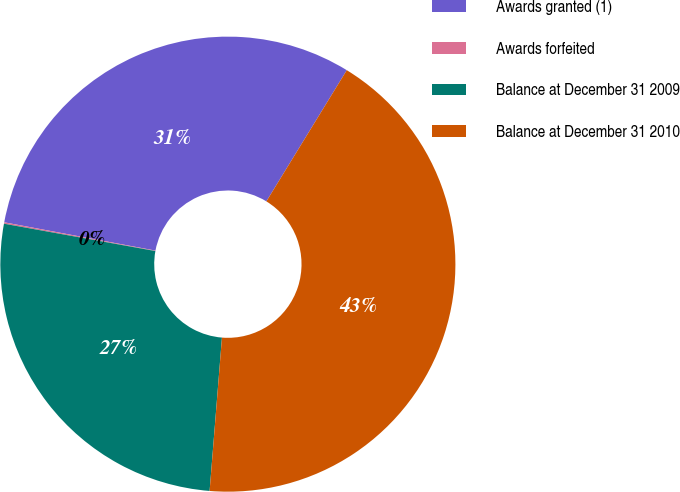Convert chart to OTSL. <chart><loc_0><loc_0><loc_500><loc_500><pie_chart><fcel>Awards granted (1)<fcel>Awards forfeited<fcel>Balance at December 31 2009<fcel>Balance at December 31 2010<nl><fcel>30.81%<fcel>0.1%<fcel>26.57%<fcel>42.53%<nl></chart> 